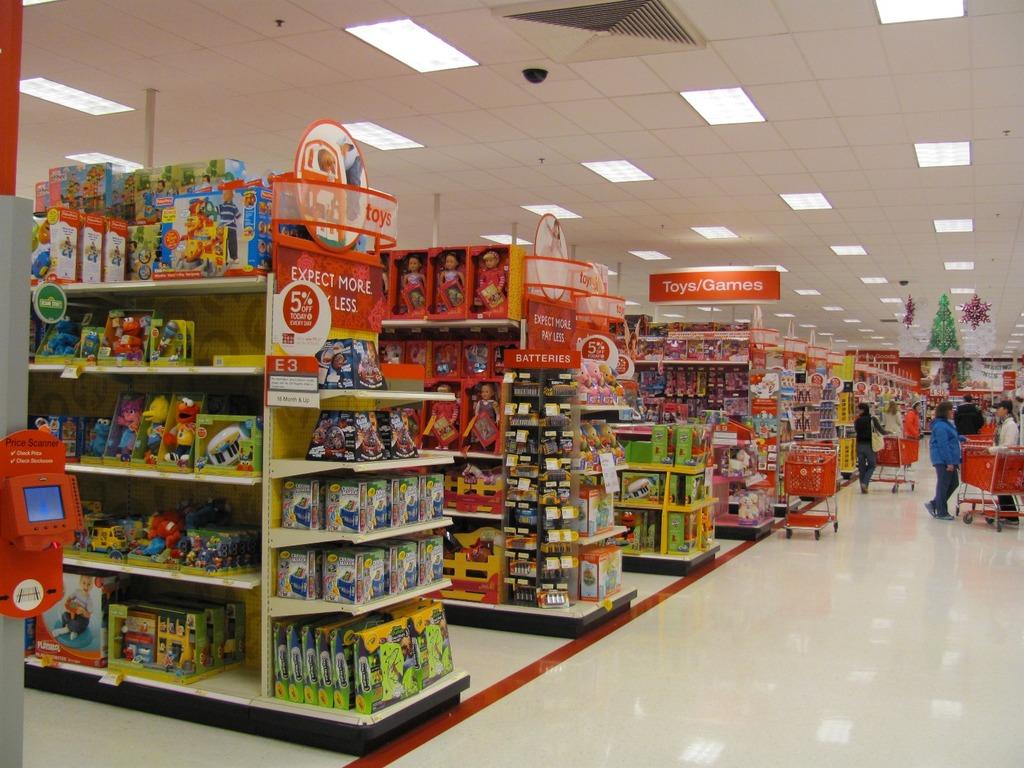What does the nearby aisle contain?
Offer a terse response. Toys. What should you expect?
Give a very brief answer. More. 